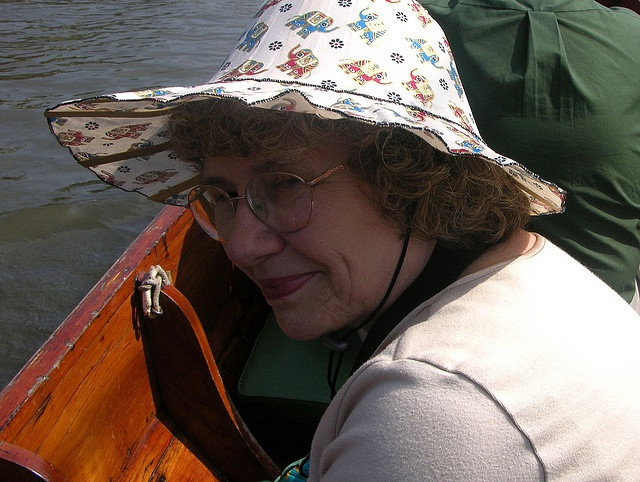Describe the objects in this image and their specific colors. I can see people in black, white, gray, and maroon tones, boat in black, maroon, and brown tones, and people in black, darkgreen, and gray tones in this image. 